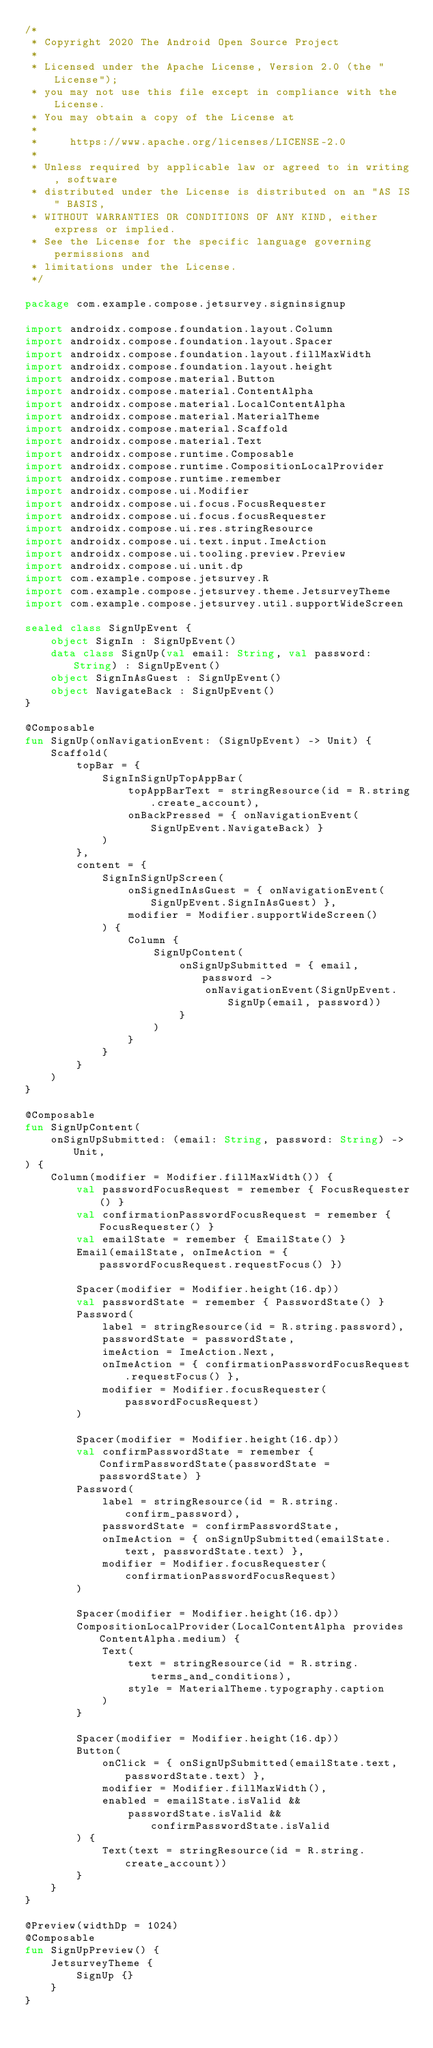Convert code to text. <code><loc_0><loc_0><loc_500><loc_500><_Kotlin_>/*
 * Copyright 2020 The Android Open Source Project
 *
 * Licensed under the Apache License, Version 2.0 (the "License");
 * you may not use this file except in compliance with the License.
 * You may obtain a copy of the License at
 *
 *     https://www.apache.org/licenses/LICENSE-2.0
 *
 * Unless required by applicable law or agreed to in writing, software
 * distributed under the License is distributed on an "AS IS" BASIS,
 * WITHOUT WARRANTIES OR CONDITIONS OF ANY KIND, either express or implied.
 * See the License for the specific language governing permissions and
 * limitations under the License.
 */

package com.example.compose.jetsurvey.signinsignup

import androidx.compose.foundation.layout.Column
import androidx.compose.foundation.layout.Spacer
import androidx.compose.foundation.layout.fillMaxWidth
import androidx.compose.foundation.layout.height
import androidx.compose.material.Button
import androidx.compose.material.ContentAlpha
import androidx.compose.material.LocalContentAlpha
import androidx.compose.material.MaterialTheme
import androidx.compose.material.Scaffold
import androidx.compose.material.Text
import androidx.compose.runtime.Composable
import androidx.compose.runtime.CompositionLocalProvider
import androidx.compose.runtime.remember
import androidx.compose.ui.Modifier
import androidx.compose.ui.focus.FocusRequester
import androidx.compose.ui.focus.focusRequester
import androidx.compose.ui.res.stringResource
import androidx.compose.ui.text.input.ImeAction
import androidx.compose.ui.tooling.preview.Preview
import androidx.compose.ui.unit.dp
import com.example.compose.jetsurvey.R
import com.example.compose.jetsurvey.theme.JetsurveyTheme
import com.example.compose.jetsurvey.util.supportWideScreen

sealed class SignUpEvent {
    object SignIn : SignUpEvent()
    data class SignUp(val email: String, val password: String) : SignUpEvent()
    object SignInAsGuest : SignUpEvent()
    object NavigateBack : SignUpEvent()
}

@Composable
fun SignUp(onNavigationEvent: (SignUpEvent) -> Unit) {
    Scaffold(
        topBar = {
            SignInSignUpTopAppBar(
                topAppBarText = stringResource(id = R.string.create_account),
                onBackPressed = { onNavigationEvent(SignUpEvent.NavigateBack) }
            )
        },
        content = {
            SignInSignUpScreen(
                onSignedInAsGuest = { onNavigationEvent(SignUpEvent.SignInAsGuest) },
                modifier = Modifier.supportWideScreen()
            ) {
                Column {
                    SignUpContent(
                        onSignUpSubmitted = { email, password ->
                            onNavigationEvent(SignUpEvent.SignUp(email, password))
                        }
                    )
                }
            }
        }
    )
}

@Composable
fun SignUpContent(
    onSignUpSubmitted: (email: String, password: String) -> Unit,
) {
    Column(modifier = Modifier.fillMaxWidth()) {
        val passwordFocusRequest = remember { FocusRequester() }
        val confirmationPasswordFocusRequest = remember { FocusRequester() }
        val emailState = remember { EmailState() }
        Email(emailState, onImeAction = { passwordFocusRequest.requestFocus() })

        Spacer(modifier = Modifier.height(16.dp))
        val passwordState = remember { PasswordState() }
        Password(
            label = stringResource(id = R.string.password),
            passwordState = passwordState,
            imeAction = ImeAction.Next,
            onImeAction = { confirmationPasswordFocusRequest.requestFocus() },
            modifier = Modifier.focusRequester(passwordFocusRequest)
        )

        Spacer(modifier = Modifier.height(16.dp))
        val confirmPasswordState = remember { ConfirmPasswordState(passwordState = passwordState) }
        Password(
            label = stringResource(id = R.string.confirm_password),
            passwordState = confirmPasswordState,
            onImeAction = { onSignUpSubmitted(emailState.text, passwordState.text) },
            modifier = Modifier.focusRequester(confirmationPasswordFocusRequest)
        )

        Spacer(modifier = Modifier.height(16.dp))
        CompositionLocalProvider(LocalContentAlpha provides ContentAlpha.medium) {
            Text(
                text = stringResource(id = R.string.terms_and_conditions),
                style = MaterialTheme.typography.caption
            )
        }

        Spacer(modifier = Modifier.height(16.dp))
        Button(
            onClick = { onSignUpSubmitted(emailState.text, passwordState.text) },
            modifier = Modifier.fillMaxWidth(),
            enabled = emailState.isValid &&
                passwordState.isValid && confirmPasswordState.isValid
        ) {
            Text(text = stringResource(id = R.string.create_account))
        }
    }
}

@Preview(widthDp = 1024)
@Composable
fun SignUpPreview() {
    JetsurveyTheme {
        SignUp {}
    }
}
</code> 